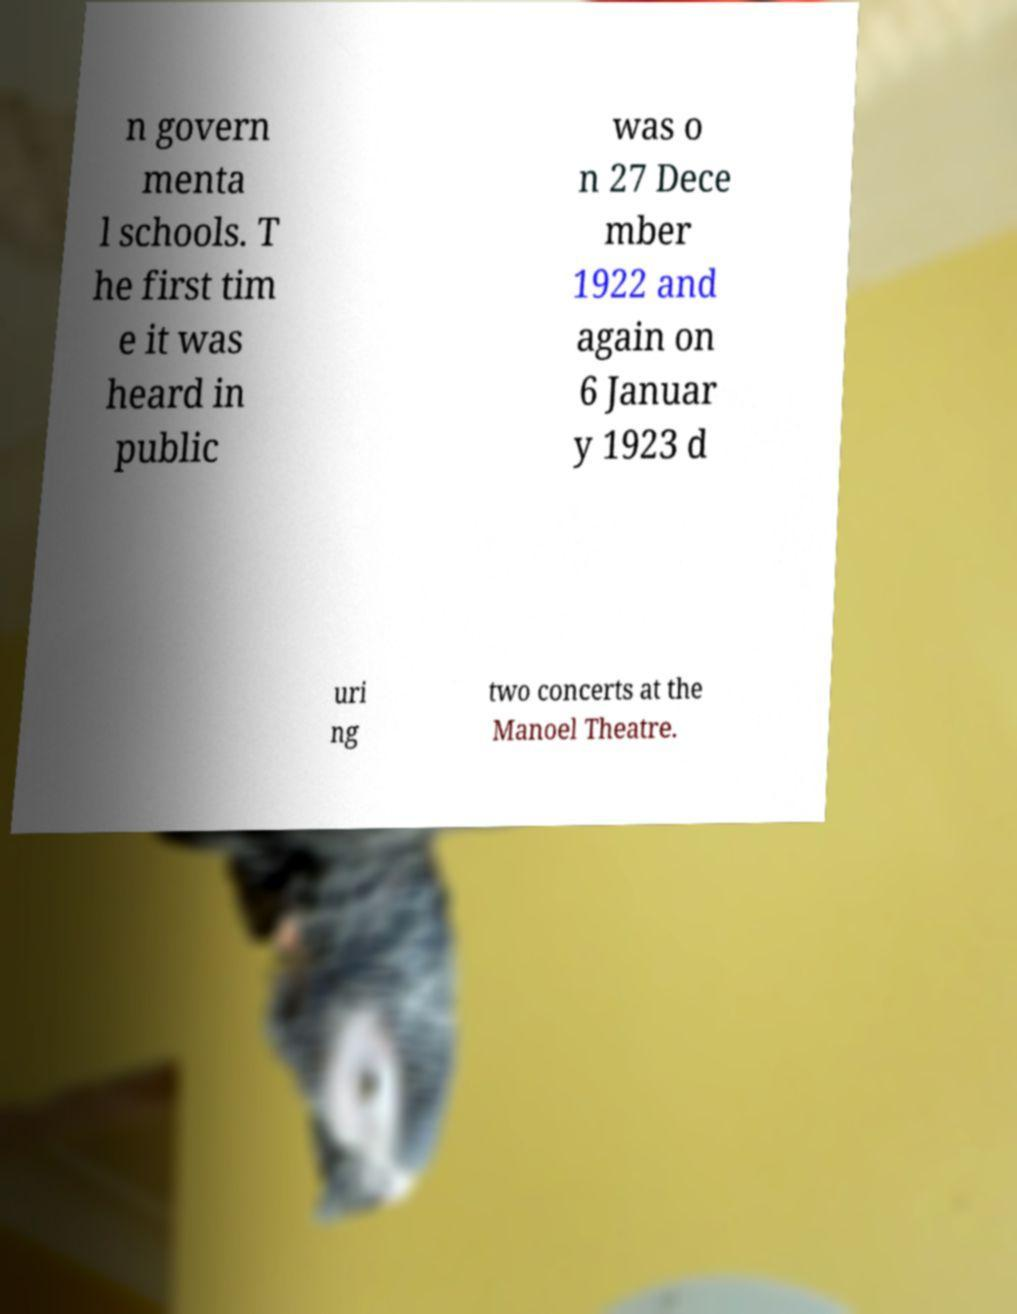Please identify and transcribe the text found in this image. n govern menta l schools. T he first tim e it was heard in public was o n 27 Dece mber 1922 and again on 6 Januar y 1923 d uri ng two concerts at the Manoel Theatre. 